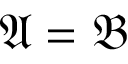Convert formula to latex. <formula><loc_0><loc_0><loc_500><loc_500>{ \mathfrak { A } } = { \mathfrak { B } }</formula> 